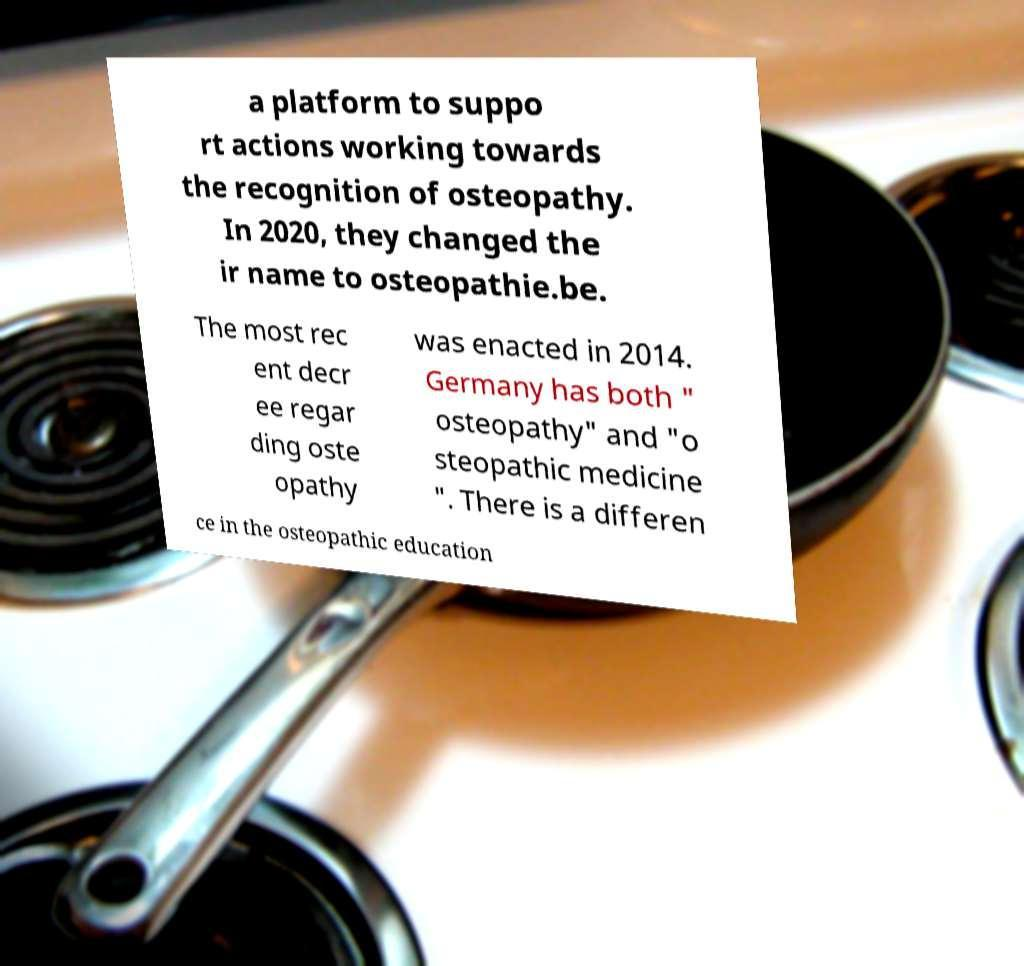I need the written content from this picture converted into text. Can you do that? a platform to suppo rt actions working towards the recognition of osteopathy. In 2020, they changed the ir name to osteopathie.be. The most rec ent decr ee regar ding oste opathy was enacted in 2014. Germany has both " osteopathy" and "o steopathic medicine ". There is a differen ce in the osteopathic education 